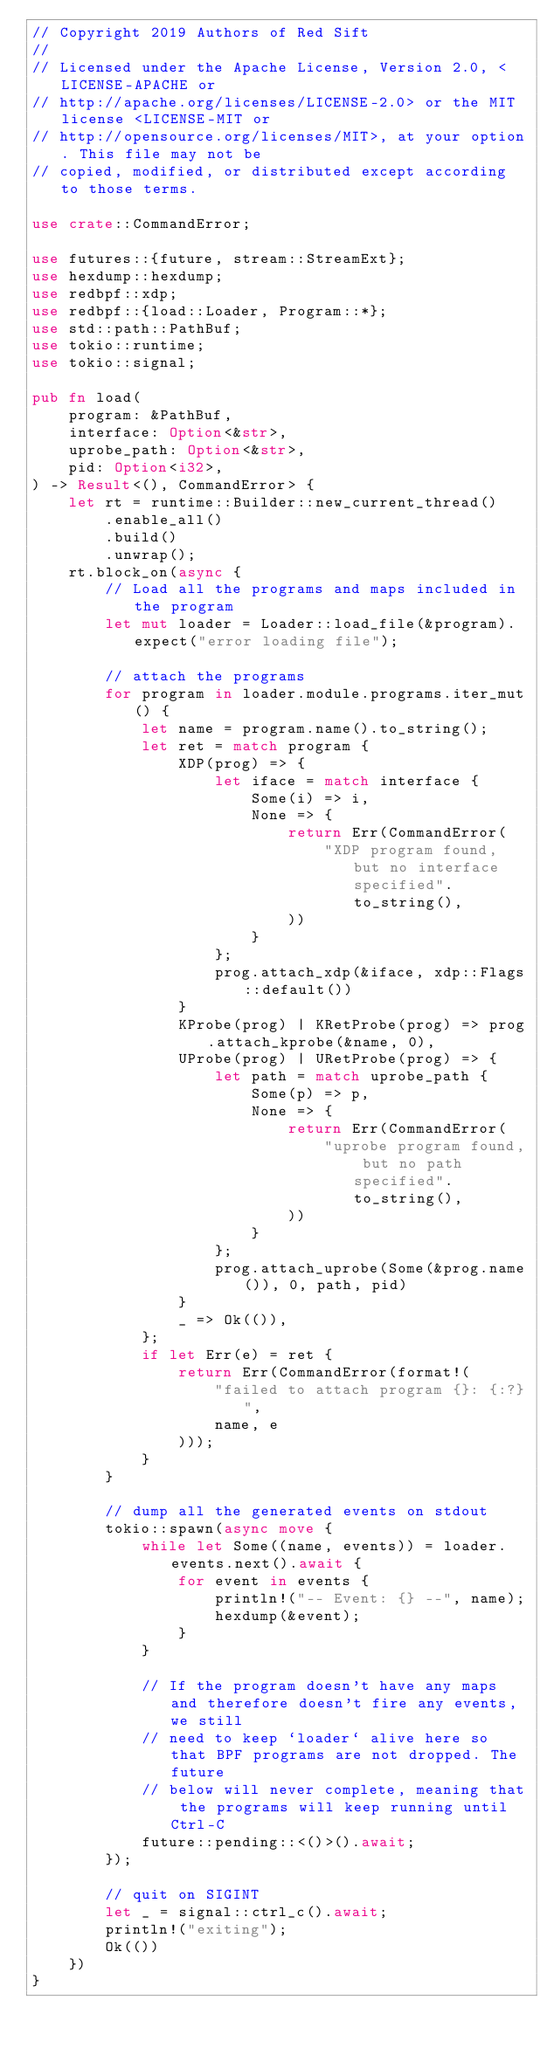Convert code to text. <code><loc_0><loc_0><loc_500><loc_500><_Rust_>// Copyright 2019 Authors of Red Sift
//
// Licensed under the Apache License, Version 2.0, <LICENSE-APACHE or
// http://apache.org/licenses/LICENSE-2.0> or the MIT license <LICENSE-MIT or
// http://opensource.org/licenses/MIT>, at your option. This file may not be
// copied, modified, or distributed except according to those terms.

use crate::CommandError;

use futures::{future, stream::StreamExt};
use hexdump::hexdump;
use redbpf::xdp;
use redbpf::{load::Loader, Program::*};
use std::path::PathBuf;
use tokio::runtime;
use tokio::signal;

pub fn load(
    program: &PathBuf,
    interface: Option<&str>,
    uprobe_path: Option<&str>,
    pid: Option<i32>,
) -> Result<(), CommandError> {
    let rt = runtime::Builder::new_current_thread()
        .enable_all()
        .build()
        .unwrap();
    rt.block_on(async {
        // Load all the programs and maps included in the program
        let mut loader = Loader::load_file(&program).expect("error loading file");

        // attach the programs
        for program in loader.module.programs.iter_mut() {
            let name = program.name().to_string();
            let ret = match program {
                XDP(prog) => {
                    let iface = match interface {
                        Some(i) => i,
                        None => {
                            return Err(CommandError(
                                "XDP program found, but no interface specified".to_string(),
                            ))
                        }
                    };
                    prog.attach_xdp(&iface, xdp::Flags::default())
                }
                KProbe(prog) | KRetProbe(prog) => prog.attach_kprobe(&name, 0),
                UProbe(prog) | URetProbe(prog) => {
                    let path = match uprobe_path {
                        Some(p) => p,
                        None => {
                            return Err(CommandError(
                                "uprobe program found, but no path specified".to_string(),
                            ))
                        }
                    };
                    prog.attach_uprobe(Some(&prog.name()), 0, path, pid)
                }
                _ => Ok(()),
            };
            if let Err(e) = ret {
                return Err(CommandError(format!(
                    "failed to attach program {}: {:?}",
                    name, e
                )));
            }
        }

        // dump all the generated events on stdout
        tokio::spawn(async move {
            while let Some((name, events)) = loader.events.next().await {
                for event in events {
                    println!("-- Event: {} --", name);
                    hexdump(&event);
                }
            }

            // If the program doesn't have any maps and therefore doesn't fire any events, we still
            // need to keep `loader` alive here so that BPF programs are not dropped. The future
            // below will never complete, meaning that the programs will keep running until Ctrl-C
            future::pending::<()>().await;
        });

        // quit on SIGINT
        let _ = signal::ctrl_c().await;
        println!("exiting");
        Ok(())
    })
}
</code> 